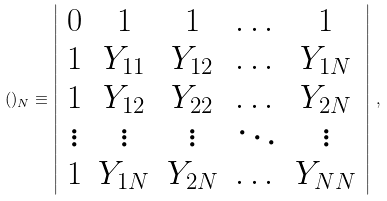<formula> <loc_0><loc_0><loc_500><loc_500>( ) _ { N } \equiv \left | \begin{array} { c c c c c } 0 & 1 & 1 & \dots & 1 \\ 1 & Y _ { 1 1 } & Y _ { 1 2 } & \dots & Y _ { 1 N } \\ 1 & Y _ { 1 2 } & Y _ { 2 2 } & \dots & Y _ { 2 N } \\ \vdots & \vdots & \vdots & \ddots & \vdots \\ 1 & Y _ { 1 N } & Y _ { 2 N } & \dots & Y _ { N N } \end{array} \right | \, ,</formula> 